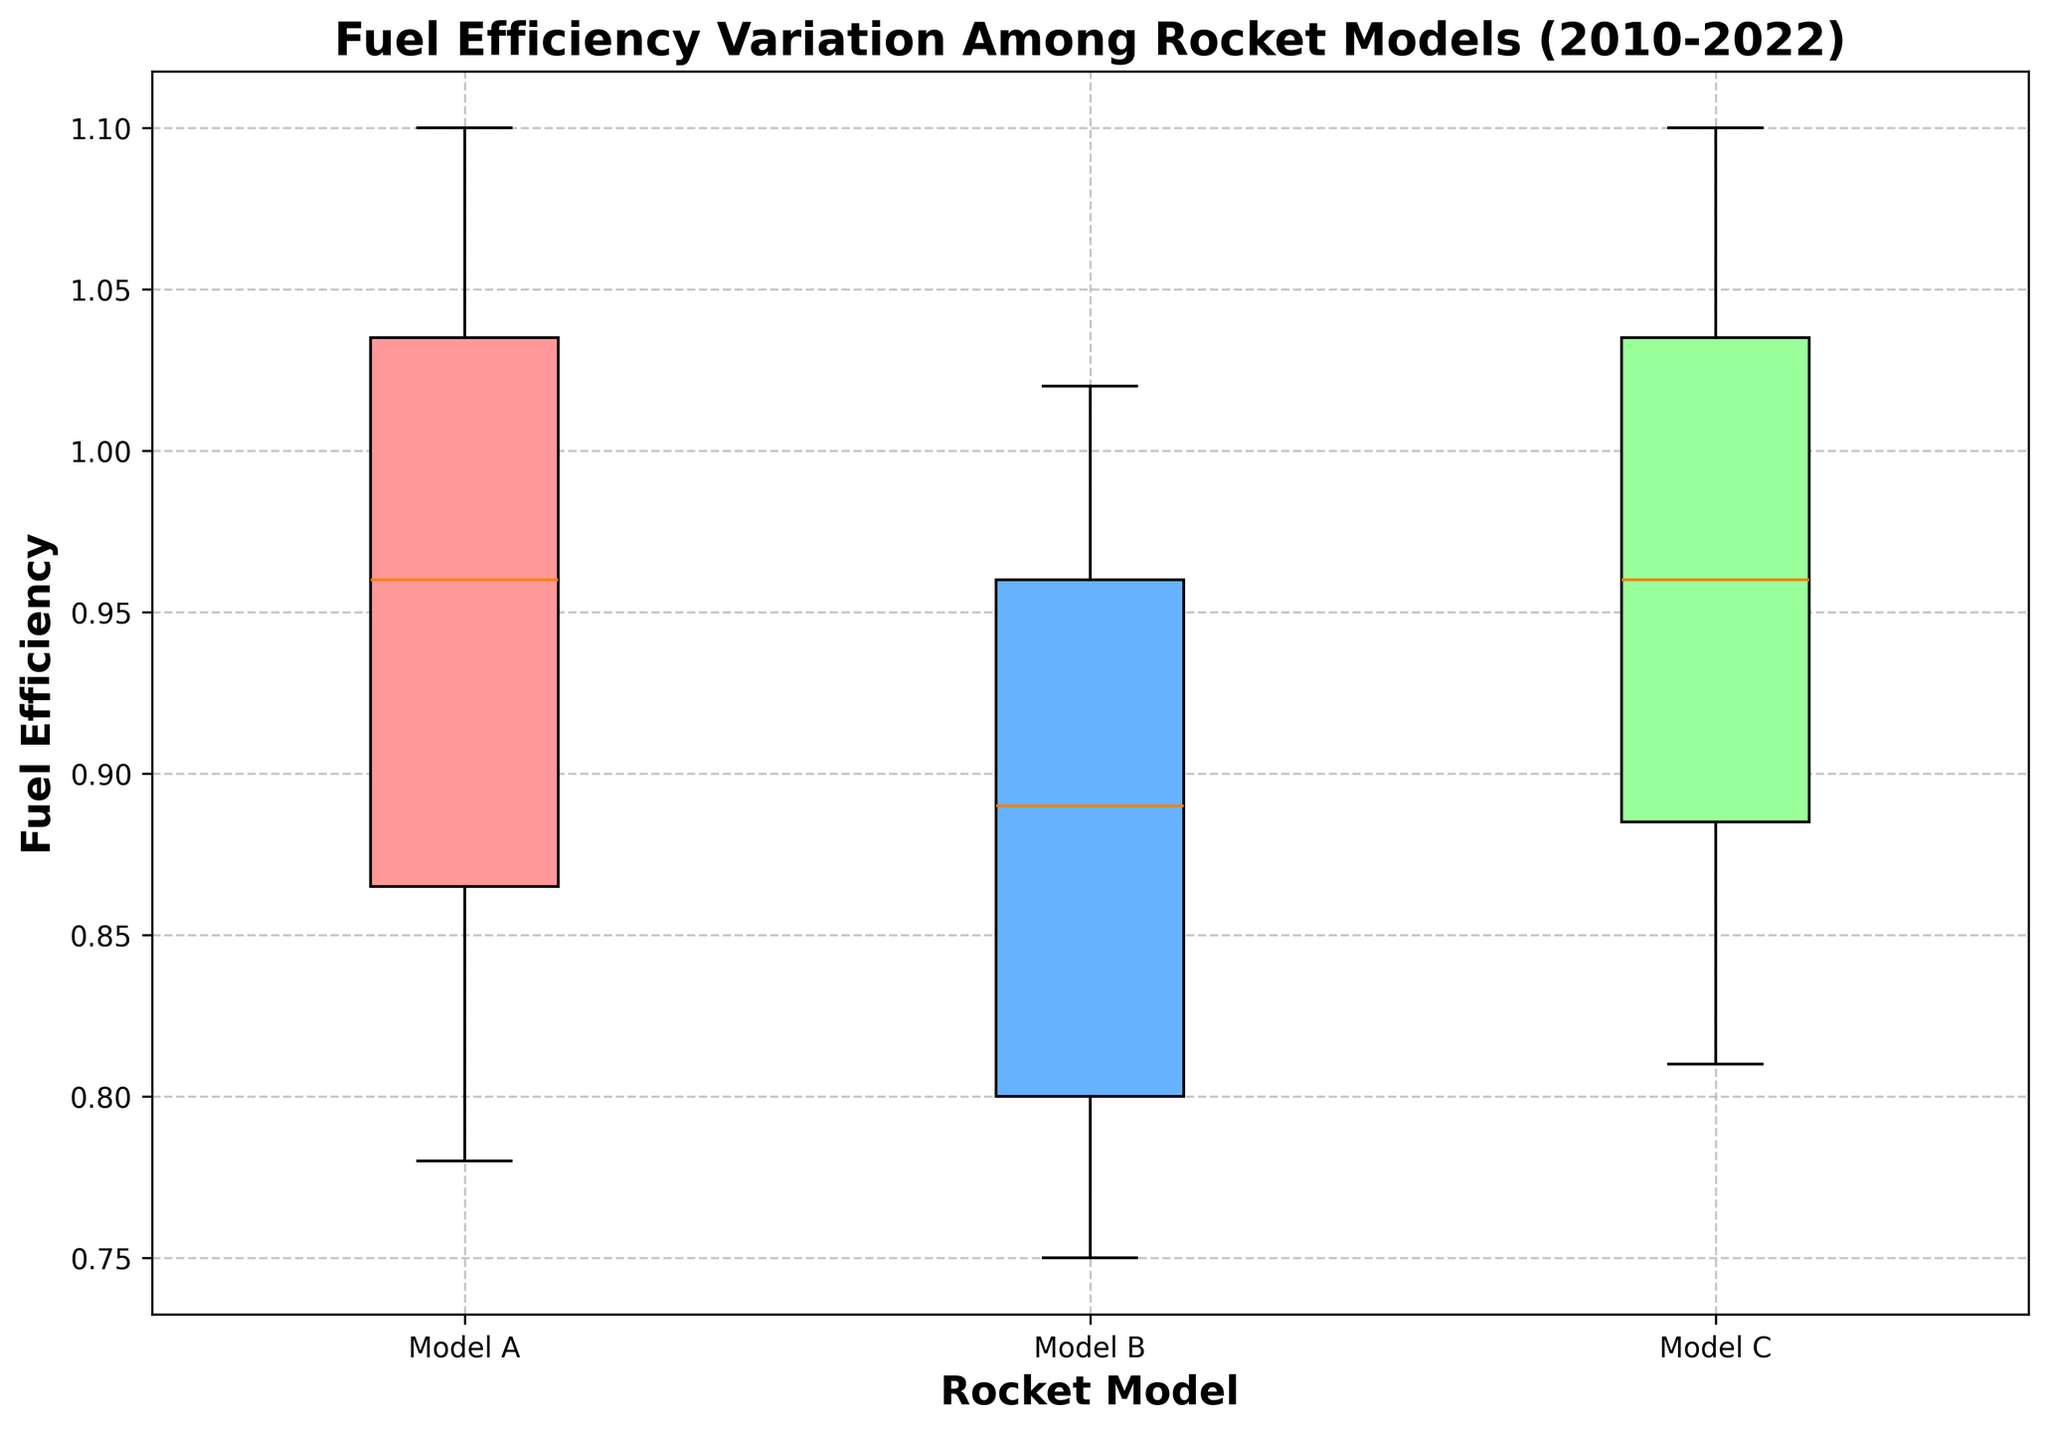What is the median fuel efficiency of Model A? To find the median, look at the middle value of the dataset for Model A. The box plot shows the line inside the box representing the median value of Model A.
Answer: Approximately 0.99 Among the three rocket models, which model shows the highest variability in fuel efficiency? Variability in a box plot can be observed by the interquartile range (IQR), which is the length of the box. Model C has the longest box, indicating the highest variability.
Answer: Model C How does the median fuel efficiency of Model B compare to Model C? The median is indicated by the line inside each box. Model C's median line is higher than Model B's, showing that Model C has a higher median fuel efficiency.
Answer: Model C's median is higher than Model B's What is the range of fuel efficiency for Model C? The range is the difference between the minimum and maximum values. For Model C, this is the distance from the bottom whisker to the top whisker.
Answer: Approximately 0.82 to 1.1 Which rocket model has the lowest third quartile (Q3) value? The third quartile is the top of the box in the plot. The lowest third quartile line among the three models is observed in Model B.
Answer: Model B In which rocket model is the difference between the median and the first quartile (Q1) the smallest? Look at the distance between the median line and the bottom of each box (Q1). The smallest distance is in Model B.
Answer: Model B What is the interquartile range (IQR) for Model A? The IQR is the difference between the third quartile (Q3) and the first quartile (Q1). From the box plot, identify the top and bottom of the box for Model A and compute the difference. For Model A, Q3 is around 1.06 and Q1 is around 0.89.
Answer: Approximately 0.17 How does the overall distribution of fuel efficiency in Model B compare to Model A? Compare the positions and lengths of the boxes and whiskers. Model A generally has higher fuel efficiency values than Model B, and its distribution spread (box size) is more compact.
Answer: Model A has higher and more compact efficiency values Which model shows the most improvement in median fuel efficiency over the years? Improvement trends can best be assessed by looking at successive box plots over the years for each model in a sequential plot (not provided, based on a hypothetical assumption). Here, if we consider Model A generally increasing median values, it suggests significant improvement.
Answer: Model A Do any of the models have any outliers in their fuel efficiency data? Outliers are typically indicated by dots outside the whiskers in a box plot. If none of the box plots have dots outside their whiskers, then we can assume there are no outliers.
Answer: No, there are no visible outliers 